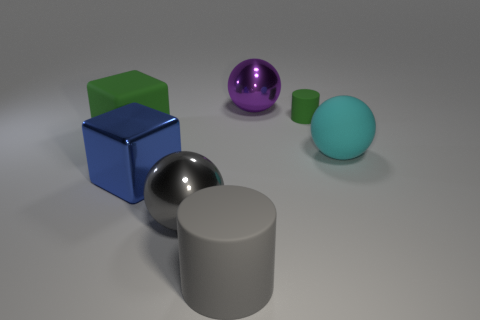There is a gray object that is the same shape as the large cyan thing; what is its size?
Make the answer very short. Large. How many big blue blocks have the same material as the small green cylinder?
Offer a very short reply. 0. Is the material of the big cube that is behind the large cyan thing the same as the big gray ball?
Ensure brevity in your answer.  No. Is the number of blue metal cubes that are right of the purple ball the same as the number of gray rubber objects?
Keep it short and to the point. No. How big is the cyan object?
Keep it short and to the point. Large. What material is the big cube that is the same color as the small matte thing?
Keep it short and to the point. Rubber. What number of tiny metallic balls are the same color as the rubber cube?
Your answer should be compact. 0. Is the size of the gray metallic object the same as the blue object?
Provide a succinct answer. Yes. There is a metallic ball to the left of the purple sphere to the right of the large green matte thing; what is its size?
Your answer should be very brief. Large. There is a small object; does it have the same color as the big block in front of the large cyan matte object?
Your answer should be very brief. No. 